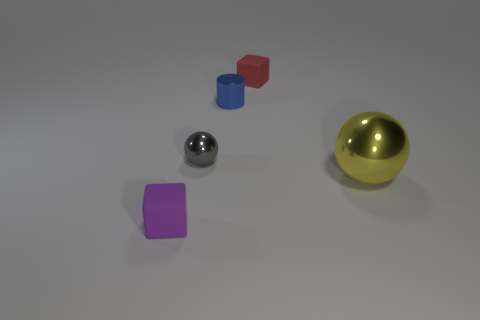There is a sphere that is made of the same material as the small gray thing; what color is it?
Provide a succinct answer. Yellow. Is there a gray cylinder of the same size as the purple rubber object?
Make the answer very short. No. Is the number of small red rubber things behind the red rubber object greater than the number of shiny things that are behind the big sphere?
Your answer should be compact. No. Is the material of the tiny thing behind the blue shiny object the same as the tiny thing in front of the small ball?
Keep it short and to the point. Yes. What shape is the gray metal thing that is the same size as the purple matte thing?
Your response must be concise. Sphere. Are there any red rubber objects that have the same shape as the big yellow thing?
Offer a very short reply. No. Is the color of the rubber object in front of the tiny ball the same as the rubber thing that is behind the purple matte cube?
Your answer should be compact. No. Are there any matte things on the left side of the tiny gray ball?
Make the answer very short. Yes. There is a thing that is both in front of the tiny gray thing and on the left side of the red cube; what is it made of?
Keep it short and to the point. Rubber. Is the material of the tiny thing in front of the small gray metallic sphere the same as the yellow sphere?
Keep it short and to the point. No. 